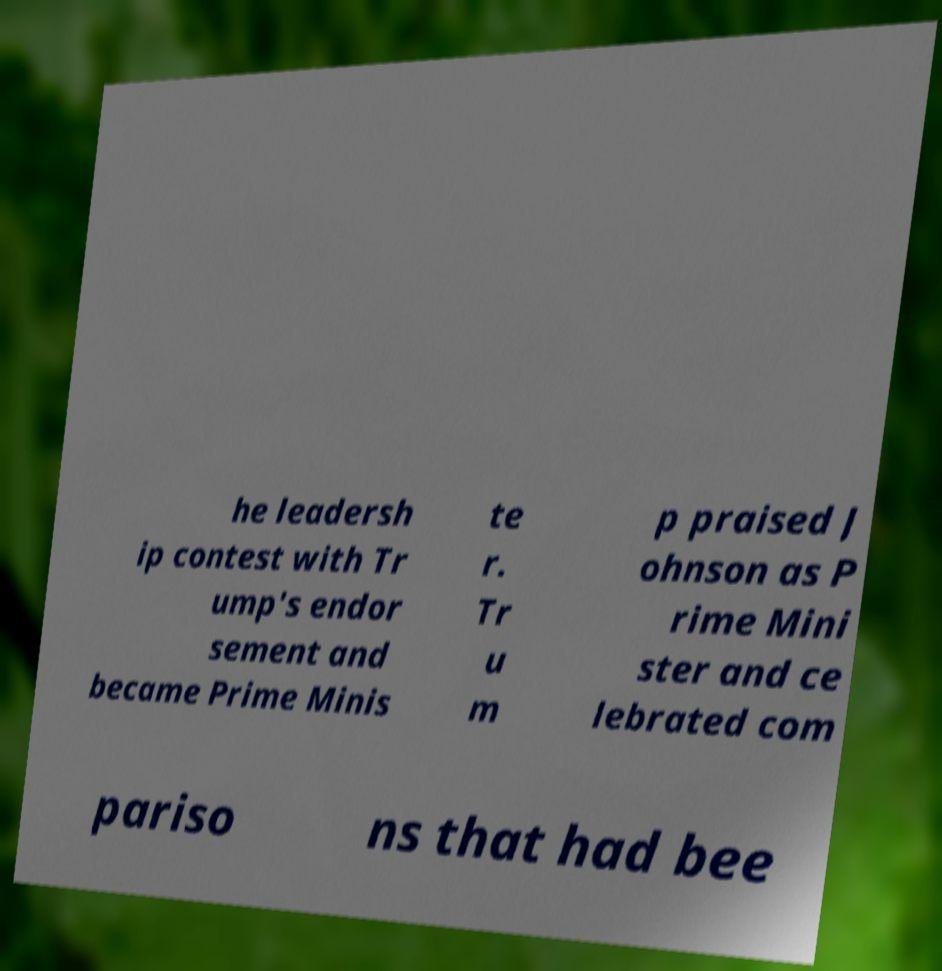Please read and relay the text visible in this image. What does it say? he leadersh ip contest with Tr ump's endor sement and became Prime Minis te r. Tr u m p praised J ohnson as P rime Mini ster and ce lebrated com pariso ns that had bee 